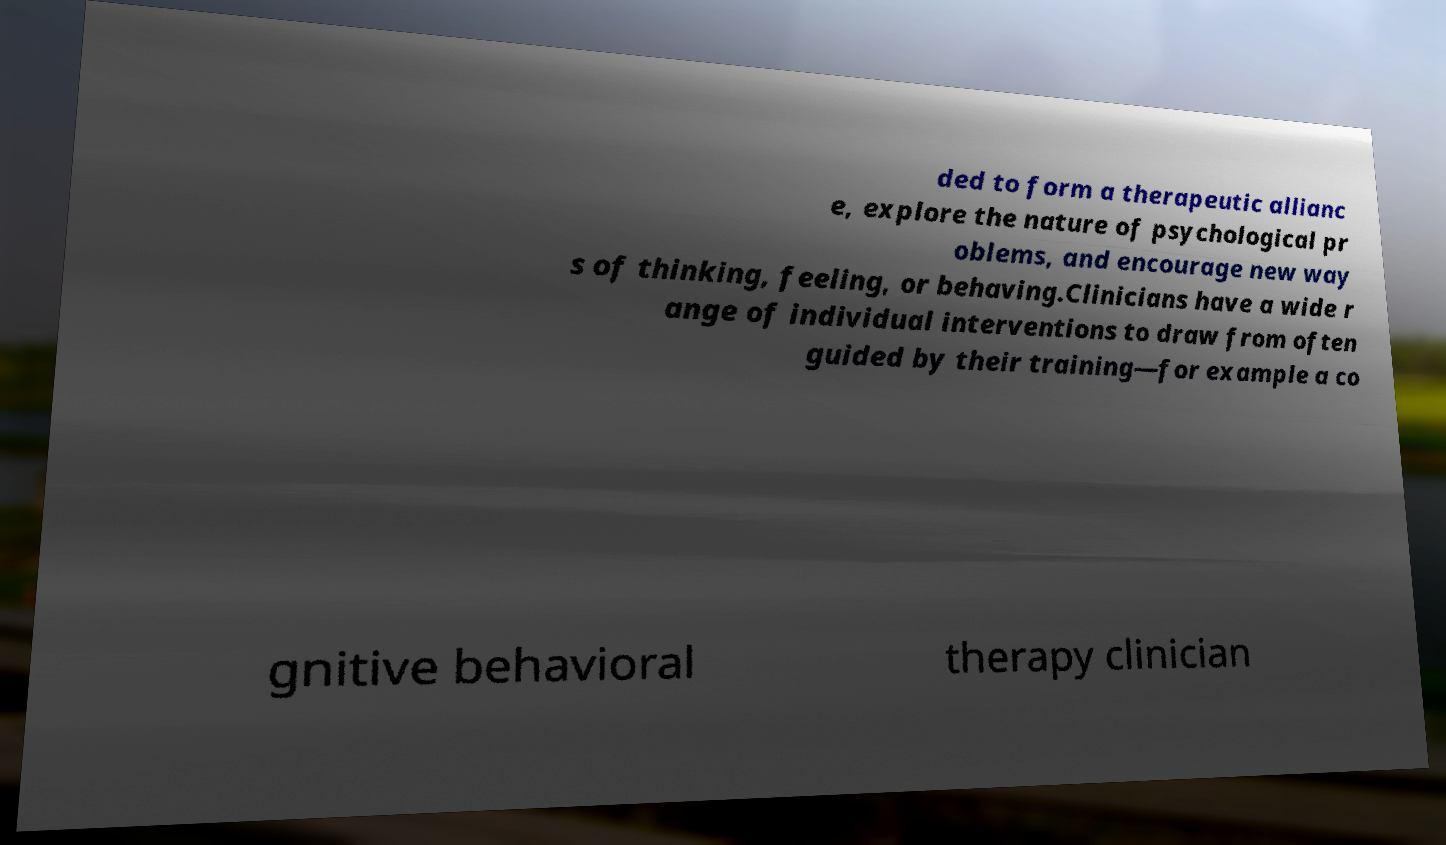Can you read and provide the text displayed in the image?This photo seems to have some interesting text. Can you extract and type it out for me? ded to form a therapeutic allianc e, explore the nature of psychological pr oblems, and encourage new way s of thinking, feeling, or behaving.Clinicians have a wide r ange of individual interventions to draw from often guided by their training—for example a co gnitive behavioral therapy clinician 